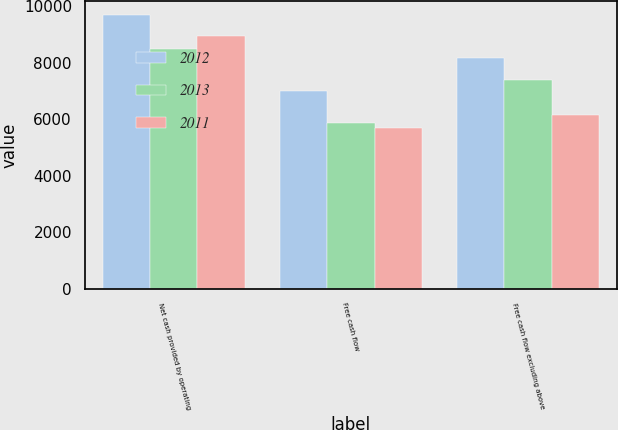Convert chart to OTSL. <chart><loc_0><loc_0><loc_500><loc_500><stacked_bar_chart><ecel><fcel>Net cash provided by operating<fcel>Free cash flow<fcel>Free cash flow excluding above<nl><fcel>2012<fcel>9688<fcel>7002<fcel>8162<nl><fcel>2013<fcel>8479<fcel>5860<fcel>7387<nl><fcel>2011<fcel>8944<fcel>5689<fcel>6145<nl></chart> 